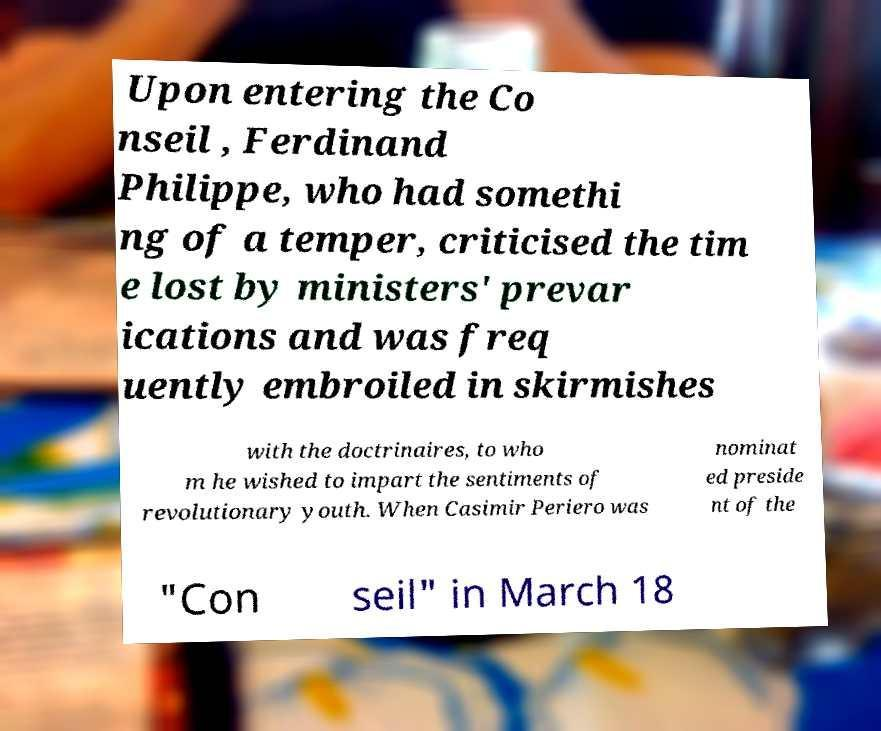Can you read and provide the text displayed in the image?This photo seems to have some interesting text. Can you extract and type it out for me? Upon entering the Co nseil , Ferdinand Philippe, who had somethi ng of a temper, criticised the tim e lost by ministers' prevar ications and was freq uently embroiled in skirmishes with the doctrinaires, to who m he wished to impart the sentiments of revolutionary youth. When Casimir Periero was nominat ed preside nt of the "Con seil" in March 18 